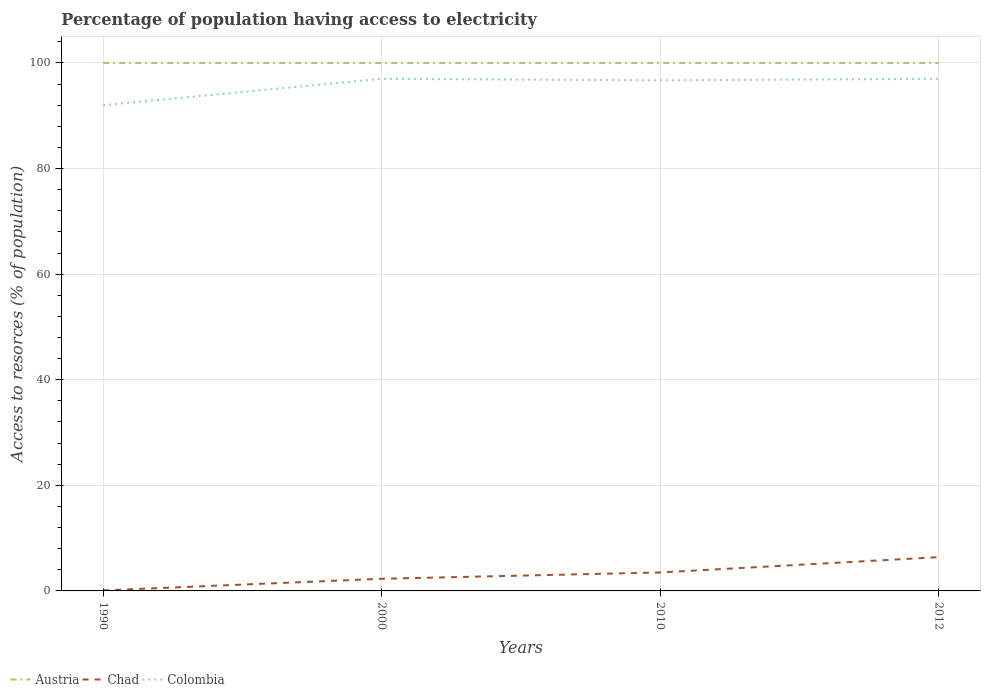Is the number of lines equal to the number of legend labels?
Your response must be concise. Yes. Across all years, what is the maximum percentage of population having access to electricity in Chad?
Ensure brevity in your answer.  0.1. In which year was the percentage of population having access to electricity in Chad maximum?
Offer a terse response. 1990. What is the total percentage of population having access to electricity in Chad in the graph?
Make the answer very short. -1.2. What is the difference between the highest and the second highest percentage of population having access to electricity in Austria?
Give a very brief answer. 0. What is the difference between the highest and the lowest percentage of population having access to electricity in Colombia?
Your response must be concise. 3. What is the difference between two consecutive major ticks on the Y-axis?
Provide a short and direct response. 20. Are the values on the major ticks of Y-axis written in scientific E-notation?
Provide a short and direct response. No. Does the graph contain any zero values?
Keep it short and to the point. No. Does the graph contain grids?
Provide a short and direct response. Yes. How many legend labels are there?
Your answer should be very brief. 3. What is the title of the graph?
Your answer should be compact. Percentage of population having access to electricity. What is the label or title of the Y-axis?
Your answer should be very brief. Access to resorces (% of population). What is the Access to resorces (% of population) of Colombia in 1990?
Your answer should be very brief. 92. What is the Access to resorces (% of population) in Colombia in 2000?
Offer a terse response. 97. What is the Access to resorces (% of population) of Chad in 2010?
Offer a very short reply. 3.5. What is the Access to resorces (% of population) of Colombia in 2010?
Give a very brief answer. 96.7. What is the Access to resorces (% of population) of Chad in 2012?
Provide a short and direct response. 6.4. What is the Access to resorces (% of population) of Colombia in 2012?
Offer a terse response. 97. Across all years, what is the maximum Access to resorces (% of population) in Austria?
Make the answer very short. 100. Across all years, what is the maximum Access to resorces (% of population) in Colombia?
Provide a short and direct response. 97. Across all years, what is the minimum Access to resorces (% of population) in Austria?
Offer a very short reply. 100. Across all years, what is the minimum Access to resorces (% of population) in Chad?
Provide a short and direct response. 0.1. Across all years, what is the minimum Access to resorces (% of population) of Colombia?
Offer a terse response. 92. What is the total Access to resorces (% of population) of Austria in the graph?
Provide a succinct answer. 400. What is the total Access to resorces (% of population) of Chad in the graph?
Offer a very short reply. 12.3. What is the total Access to resorces (% of population) of Colombia in the graph?
Provide a short and direct response. 382.7. What is the difference between the Access to resorces (% of population) of Colombia in 1990 and that in 2000?
Make the answer very short. -5. What is the difference between the Access to resorces (% of population) of Chad in 1990 and that in 2010?
Offer a terse response. -3.4. What is the difference between the Access to resorces (% of population) of Austria in 2000 and that in 2010?
Offer a terse response. 0. What is the difference between the Access to resorces (% of population) in Chad in 2000 and that in 2010?
Provide a short and direct response. -1.2. What is the difference between the Access to resorces (% of population) of Austria in 2000 and that in 2012?
Provide a short and direct response. 0. What is the difference between the Access to resorces (% of population) in Chad in 2000 and that in 2012?
Provide a succinct answer. -4.1. What is the difference between the Access to resorces (% of population) of Colombia in 2000 and that in 2012?
Give a very brief answer. 0. What is the difference between the Access to resorces (% of population) of Austria in 2010 and that in 2012?
Make the answer very short. 0. What is the difference between the Access to resorces (% of population) in Chad in 2010 and that in 2012?
Provide a succinct answer. -2.9. What is the difference between the Access to resorces (% of population) in Colombia in 2010 and that in 2012?
Provide a succinct answer. -0.3. What is the difference between the Access to resorces (% of population) in Austria in 1990 and the Access to resorces (% of population) in Chad in 2000?
Make the answer very short. 97.7. What is the difference between the Access to resorces (% of population) in Chad in 1990 and the Access to resorces (% of population) in Colombia in 2000?
Keep it short and to the point. -96.9. What is the difference between the Access to resorces (% of population) of Austria in 1990 and the Access to resorces (% of population) of Chad in 2010?
Provide a succinct answer. 96.5. What is the difference between the Access to resorces (% of population) of Austria in 1990 and the Access to resorces (% of population) of Colombia in 2010?
Offer a very short reply. 3.3. What is the difference between the Access to resorces (% of population) in Chad in 1990 and the Access to resorces (% of population) in Colombia in 2010?
Provide a succinct answer. -96.6. What is the difference between the Access to resorces (% of population) of Austria in 1990 and the Access to resorces (% of population) of Chad in 2012?
Keep it short and to the point. 93.6. What is the difference between the Access to resorces (% of population) in Austria in 1990 and the Access to resorces (% of population) in Colombia in 2012?
Your answer should be very brief. 3. What is the difference between the Access to resorces (% of population) of Chad in 1990 and the Access to resorces (% of population) of Colombia in 2012?
Keep it short and to the point. -96.9. What is the difference between the Access to resorces (% of population) in Austria in 2000 and the Access to resorces (% of population) in Chad in 2010?
Give a very brief answer. 96.5. What is the difference between the Access to resorces (% of population) of Chad in 2000 and the Access to resorces (% of population) of Colombia in 2010?
Make the answer very short. -94.4. What is the difference between the Access to resorces (% of population) in Austria in 2000 and the Access to resorces (% of population) in Chad in 2012?
Offer a very short reply. 93.6. What is the difference between the Access to resorces (% of population) of Austria in 2000 and the Access to resorces (% of population) of Colombia in 2012?
Your answer should be very brief. 3. What is the difference between the Access to resorces (% of population) of Chad in 2000 and the Access to resorces (% of population) of Colombia in 2012?
Your answer should be very brief. -94.7. What is the difference between the Access to resorces (% of population) of Austria in 2010 and the Access to resorces (% of population) of Chad in 2012?
Keep it short and to the point. 93.6. What is the difference between the Access to resorces (% of population) of Chad in 2010 and the Access to resorces (% of population) of Colombia in 2012?
Give a very brief answer. -93.5. What is the average Access to resorces (% of population) in Austria per year?
Provide a succinct answer. 100. What is the average Access to resorces (% of population) in Chad per year?
Ensure brevity in your answer.  3.08. What is the average Access to resorces (% of population) of Colombia per year?
Your response must be concise. 95.67. In the year 1990, what is the difference between the Access to resorces (% of population) of Austria and Access to resorces (% of population) of Chad?
Offer a very short reply. 99.9. In the year 1990, what is the difference between the Access to resorces (% of population) of Austria and Access to resorces (% of population) of Colombia?
Make the answer very short. 8. In the year 1990, what is the difference between the Access to resorces (% of population) of Chad and Access to resorces (% of population) of Colombia?
Give a very brief answer. -91.9. In the year 2000, what is the difference between the Access to resorces (% of population) of Austria and Access to resorces (% of population) of Chad?
Keep it short and to the point. 97.7. In the year 2000, what is the difference between the Access to resorces (% of population) in Chad and Access to resorces (% of population) in Colombia?
Your response must be concise. -94.7. In the year 2010, what is the difference between the Access to resorces (% of population) in Austria and Access to resorces (% of population) in Chad?
Provide a succinct answer. 96.5. In the year 2010, what is the difference between the Access to resorces (% of population) of Austria and Access to resorces (% of population) of Colombia?
Offer a terse response. 3.3. In the year 2010, what is the difference between the Access to resorces (% of population) in Chad and Access to resorces (% of population) in Colombia?
Provide a succinct answer. -93.2. In the year 2012, what is the difference between the Access to resorces (% of population) of Austria and Access to resorces (% of population) of Chad?
Give a very brief answer. 93.6. In the year 2012, what is the difference between the Access to resorces (% of population) in Austria and Access to resorces (% of population) in Colombia?
Ensure brevity in your answer.  3. In the year 2012, what is the difference between the Access to resorces (% of population) of Chad and Access to resorces (% of population) of Colombia?
Your answer should be compact. -90.6. What is the ratio of the Access to resorces (% of population) in Chad in 1990 to that in 2000?
Offer a very short reply. 0.04. What is the ratio of the Access to resorces (% of population) of Colombia in 1990 to that in 2000?
Provide a succinct answer. 0.95. What is the ratio of the Access to resorces (% of population) of Chad in 1990 to that in 2010?
Offer a very short reply. 0.03. What is the ratio of the Access to resorces (% of population) in Colombia in 1990 to that in 2010?
Offer a very short reply. 0.95. What is the ratio of the Access to resorces (% of population) in Austria in 1990 to that in 2012?
Ensure brevity in your answer.  1. What is the ratio of the Access to resorces (% of population) in Chad in 1990 to that in 2012?
Provide a succinct answer. 0.02. What is the ratio of the Access to resorces (% of population) in Colombia in 1990 to that in 2012?
Offer a very short reply. 0.95. What is the ratio of the Access to resorces (% of population) of Austria in 2000 to that in 2010?
Your answer should be very brief. 1. What is the ratio of the Access to resorces (% of population) in Chad in 2000 to that in 2010?
Your answer should be compact. 0.66. What is the ratio of the Access to resorces (% of population) in Colombia in 2000 to that in 2010?
Your response must be concise. 1. What is the ratio of the Access to resorces (% of population) in Chad in 2000 to that in 2012?
Your response must be concise. 0.36. What is the ratio of the Access to resorces (% of population) of Chad in 2010 to that in 2012?
Ensure brevity in your answer.  0.55. What is the difference between the highest and the second highest Access to resorces (% of population) in Austria?
Your answer should be compact. 0. What is the difference between the highest and the second highest Access to resorces (% of population) in Chad?
Make the answer very short. 2.9. What is the difference between the highest and the second highest Access to resorces (% of population) in Colombia?
Keep it short and to the point. 0. What is the difference between the highest and the lowest Access to resorces (% of population) in Austria?
Keep it short and to the point. 0. What is the difference between the highest and the lowest Access to resorces (% of population) in Chad?
Your answer should be compact. 6.3. 